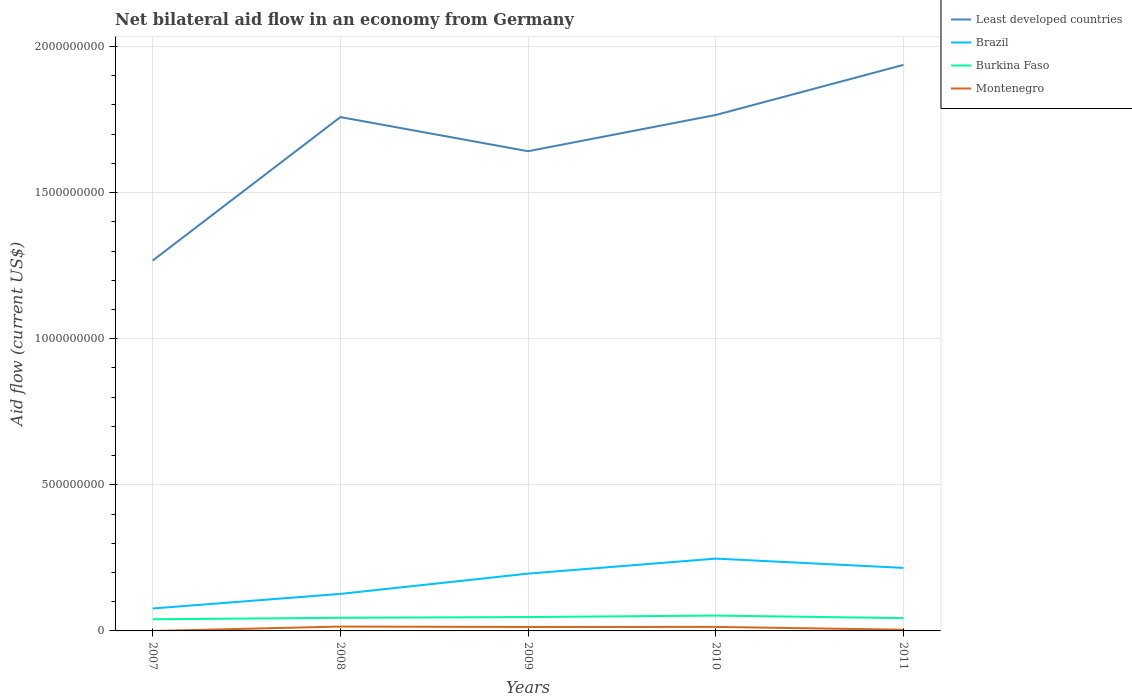How many different coloured lines are there?
Your answer should be compact. 4. Does the line corresponding to Brazil intersect with the line corresponding to Burkina Faso?
Your response must be concise. No. Across all years, what is the maximum net bilateral aid flow in Least developed countries?
Ensure brevity in your answer.  1.27e+09. What is the total net bilateral aid flow in Burkina Faso in the graph?
Offer a terse response. -3.88e+06. What is the difference between the highest and the second highest net bilateral aid flow in Least developed countries?
Offer a very short reply. 6.70e+08. Is the net bilateral aid flow in Least developed countries strictly greater than the net bilateral aid flow in Brazil over the years?
Provide a short and direct response. No. How many years are there in the graph?
Your answer should be compact. 5. What is the difference between two consecutive major ticks on the Y-axis?
Give a very brief answer. 5.00e+08. Are the values on the major ticks of Y-axis written in scientific E-notation?
Your answer should be very brief. No. Does the graph contain any zero values?
Your answer should be very brief. Yes. Does the graph contain grids?
Make the answer very short. Yes. Where does the legend appear in the graph?
Your answer should be compact. Top right. How are the legend labels stacked?
Offer a very short reply. Vertical. What is the title of the graph?
Your answer should be compact. Net bilateral aid flow in an economy from Germany. What is the label or title of the X-axis?
Make the answer very short. Years. What is the Aid flow (current US$) of Least developed countries in 2007?
Your response must be concise. 1.27e+09. What is the Aid flow (current US$) in Brazil in 2007?
Your response must be concise. 7.68e+07. What is the Aid flow (current US$) of Burkina Faso in 2007?
Provide a short and direct response. 3.99e+07. What is the Aid flow (current US$) of Least developed countries in 2008?
Provide a short and direct response. 1.76e+09. What is the Aid flow (current US$) of Brazil in 2008?
Provide a short and direct response. 1.27e+08. What is the Aid flow (current US$) of Burkina Faso in 2008?
Provide a short and direct response. 4.49e+07. What is the Aid flow (current US$) in Montenegro in 2008?
Provide a short and direct response. 1.49e+07. What is the Aid flow (current US$) in Least developed countries in 2009?
Provide a succinct answer. 1.64e+09. What is the Aid flow (current US$) in Brazil in 2009?
Provide a succinct answer. 1.96e+08. What is the Aid flow (current US$) in Burkina Faso in 2009?
Offer a very short reply. 4.75e+07. What is the Aid flow (current US$) in Montenegro in 2009?
Provide a short and direct response. 1.35e+07. What is the Aid flow (current US$) in Least developed countries in 2010?
Make the answer very short. 1.77e+09. What is the Aid flow (current US$) of Brazil in 2010?
Ensure brevity in your answer.  2.47e+08. What is the Aid flow (current US$) of Burkina Faso in 2010?
Offer a very short reply. 5.25e+07. What is the Aid flow (current US$) of Montenegro in 2010?
Make the answer very short. 1.38e+07. What is the Aid flow (current US$) in Least developed countries in 2011?
Your answer should be very brief. 1.94e+09. What is the Aid flow (current US$) of Brazil in 2011?
Offer a terse response. 2.16e+08. What is the Aid flow (current US$) in Burkina Faso in 2011?
Make the answer very short. 4.38e+07. What is the Aid flow (current US$) in Montenegro in 2011?
Make the answer very short. 4.08e+06. Across all years, what is the maximum Aid flow (current US$) of Least developed countries?
Your answer should be compact. 1.94e+09. Across all years, what is the maximum Aid flow (current US$) of Brazil?
Your answer should be compact. 2.47e+08. Across all years, what is the maximum Aid flow (current US$) of Burkina Faso?
Make the answer very short. 5.25e+07. Across all years, what is the maximum Aid flow (current US$) of Montenegro?
Your answer should be compact. 1.49e+07. Across all years, what is the minimum Aid flow (current US$) of Least developed countries?
Give a very brief answer. 1.27e+09. Across all years, what is the minimum Aid flow (current US$) in Brazil?
Offer a terse response. 7.68e+07. Across all years, what is the minimum Aid flow (current US$) in Burkina Faso?
Provide a succinct answer. 3.99e+07. Across all years, what is the minimum Aid flow (current US$) in Montenegro?
Keep it short and to the point. 0. What is the total Aid flow (current US$) of Least developed countries in the graph?
Ensure brevity in your answer.  8.37e+09. What is the total Aid flow (current US$) of Brazil in the graph?
Your response must be concise. 8.63e+08. What is the total Aid flow (current US$) of Burkina Faso in the graph?
Give a very brief answer. 2.29e+08. What is the total Aid flow (current US$) in Montenegro in the graph?
Ensure brevity in your answer.  4.62e+07. What is the difference between the Aid flow (current US$) in Least developed countries in 2007 and that in 2008?
Ensure brevity in your answer.  -4.91e+08. What is the difference between the Aid flow (current US$) of Brazil in 2007 and that in 2008?
Your answer should be compact. -4.98e+07. What is the difference between the Aid flow (current US$) of Burkina Faso in 2007 and that in 2008?
Your response must be concise. -5.02e+06. What is the difference between the Aid flow (current US$) in Least developed countries in 2007 and that in 2009?
Your answer should be very brief. -3.74e+08. What is the difference between the Aid flow (current US$) of Brazil in 2007 and that in 2009?
Offer a terse response. -1.19e+08. What is the difference between the Aid flow (current US$) in Burkina Faso in 2007 and that in 2009?
Offer a terse response. -7.60e+06. What is the difference between the Aid flow (current US$) of Least developed countries in 2007 and that in 2010?
Keep it short and to the point. -4.98e+08. What is the difference between the Aid flow (current US$) in Brazil in 2007 and that in 2010?
Your response must be concise. -1.71e+08. What is the difference between the Aid flow (current US$) of Burkina Faso in 2007 and that in 2010?
Keep it short and to the point. -1.26e+07. What is the difference between the Aid flow (current US$) of Least developed countries in 2007 and that in 2011?
Your answer should be compact. -6.70e+08. What is the difference between the Aid flow (current US$) in Brazil in 2007 and that in 2011?
Your answer should be compact. -1.39e+08. What is the difference between the Aid flow (current US$) of Burkina Faso in 2007 and that in 2011?
Your answer should be compact. -3.88e+06. What is the difference between the Aid flow (current US$) in Least developed countries in 2008 and that in 2009?
Ensure brevity in your answer.  1.17e+08. What is the difference between the Aid flow (current US$) of Brazil in 2008 and that in 2009?
Provide a short and direct response. -6.94e+07. What is the difference between the Aid flow (current US$) in Burkina Faso in 2008 and that in 2009?
Your response must be concise. -2.58e+06. What is the difference between the Aid flow (current US$) in Montenegro in 2008 and that in 2009?
Offer a very short reply. 1.44e+06. What is the difference between the Aid flow (current US$) of Least developed countries in 2008 and that in 2010?
Ensure brevity in your answer.  -7.21e+06. What is the difference between the Aid flow (current US$) of Brazil in 2008 and that in 2010?
Offer a very short reply. -1.21e+08. What is the difference between the Aid flow (current US$) in Burkina Faso in 2008 and that in 2010?
Offer a terse response. -7.59e+06. What is the difference between the Aid flow (current US$) of Montenegro in 2008 and that in 2010?
Provide a succinct answer. 1.17e+06. What is the difference between the Aid flow (current US$) of Least developed countries in 2008 and that in 2011?
Offer a terse response. -1.79e+08. What is the difference between the Aid flow (current US$) in Brazil in 2008 and that in 2011?
Ensure brevity in your answer.  -8.91e+07. What is the difference between the Aid flow (current US$) of Burkina Faso in 2008 and that in 2011?
Provide a short and direct response. 1.14e+06. What is the difference between the Aid flow (current US$) in Montenegro in 2008 and that in 2011?
Provide a short and direct response. 1.08e+07. What is the difference between the Aid flow (current US$) of Least developed countries in 2009 and that in 2010?
Your answer should be compact. -1.24e+08. What is the difference between the Aid flow (current US$) in Brazil in 2009 and that in 2010?
Offer a terse response. -5.14e+07. What is the difference between the Aid flow (current US$) in Burkina Faso in 2009 and that in 2010?
Provide a short and direct response. -5.01e+06. What is the difference between the Aid flow (current US$) of Montenegro in 2009 and that in 2010?
Provide a succinct answer. -2.70e+05. What is the difference between the Aid flow (current US$) of Least developed countries in 2009 and that in 2011?
Make the answer very short. -2.95e+08. What is the difference between the Aid flow (current US$) in Brazil in 2009 and that in 2011?
Offer a very short reply. -1.96e+07. What is the difference between the Aid flow (current US$) of Burkina Faso in 2009 and that in 2011?
Offer a very short reply. 3.72e+06. What is the difference between the Aid flow (current US$) in Montenegro in 2009 and that in 2011?
Provide a succinct answer. 9.40e+06. What is the difference between the Aid flow (current US$) in Least developed countries in 2010 and that in 2011?
Provide a short and direct response. -1.71e+08. What is the difference between the Aid flow (current US$) in Brazil in 2010 and that in 2011?
Your answer should be very brief. 3.17e+07. What is the difference between the Aid flow (current US$) in Burkina Faso in 2010 and that in 2011?
Ensure brevity in your answer.  8.73e+06. What is the difference between the Aid flow (current US$) in Montenegro in 2010 and that in 2011?
Your response must be concise. 9.67e+06. What is the difference between the Aid flow (current US$) in Least developed countries in 2007 and the Aid flow (current US$) in Brazil in 2008?
Provide a succinct answer. 1.14e+09. What is the difference between the Aid flow (current US$) of Least developed countries in 2007 and the Aid flow (current US$) of Burkina Faso in 2008?
Your answer should be very brief. 1.22e+09. What is the difference between the Aid flow (current US$) in Least developed countries in 2007 and the Aid flow (current US$) in Montenegro in 2008?
Your answer should be very brief. 1.25e+09. What is the difference between the Aid flow (current US$) of Brazil in 2007 and the Aid flow (current US$) of Burkina Faso in 2008?
Give a very brief answer. 3.19e+07. What is the difference between the Aid flow (current US$) of Brazil in 2007 and the Aid flow (current US$) of Montenegro in 2008?
Ensure brevity in your answer.  6.19e+07. What is the difference between the Aid flow (current US$) of Burkina Faso in 2007 and the Aid flow (current US$) of Montenegro in 2008?
Make the answer very short. 2.50e+07. What is the difference between the Aid flow (current US$) in Least developed countries in 2007 and the Aid flow (current US$) in Brazil in 2009?
Offer a terse response. 1.07e+09. What is the difference between the Aid flow (current US$) in Least developed countries in 2007 and the Aid flow (current US$) in Burkina Faso in 2009?
Your response must be concise. 1.22e+09. What is the difference between the Aid flow (current US$) of Least developed countries in 2007 and the Aid flow (current US$) of Montenegro in 2009?
Offer a very short reply. 1.25e+09. What is the difference between the Aid flow (current US$) in Brazil in 2007 and the Aid flow (current US$) in Burkina Faso in 2009?
Offer a very short reply. 2.93e+07. What is the difference between the Aid flow (current US$) in Brazil in 2007 and the Aid flow (current US$) in Montenegro in 2009?
Keep it short and to the point. 6.33e+07. What is the difference between the Aid flow (current US$) in Burkina Faso in 2007 and the Aid flow (current US$) in Montenegro in 2009?
Offer a terse response. 2.64e+07. What is the difference between the Aid flow (current US$) in Least developed countries in 2007 and the Aid flow (current US$) in Brazil in 2010?
Make the answer very short. 1.02e+09. What is the difference between the Aid flow (current US$) in Least developed countries in 2007 and the Aid flow (current US$) in Burkina Faso in 2010?
Offer a terse response. 1.21e+09. What is the difference between the Aid flow (current US$) of Least developed countries in 2007 and the Aid flow (current US$) of Montenegro in 2010?
Provide a succinct answer. 1.25e+09. What is the difference between the Aid flow (current US$) in Brazil in 2007 and the Aid flow (current US$) in Burkina Faso in 2010?
Offer a terse response. 2.43e+07. What is the difference between the Aid flow (current US$) of Brazil in 2007 and the Aid flow (current US$) of Montenegro in 2010?
Provide a short and direct response. 6.30e+07. What is the difference between the Aid flow (current US$) in Burkina Faso in 2007 and the Aid flow (current US$) in Montenegro in 2010?
Your response must be concise. 2.62e+07. What is the difference between the Aid flow (current US$) in Least developed countries in 2007 and the Aid flow (current US$) in Brazil in 2011?
Your answer should be compact. 1.05e+09. What is the difference between the Aid flow (current US$) of Least developed countries in 2007 and the Aid flow (current US$) of Burkina Faso in 2011?
Provide a succinct answer. 1.22e+09. What is the difference between the Aid flow (current US$) of Least developed countries in 2007 and the Aid flow (current US$) of Montenegro in 2011?
Provide a succinct answer. 1.26e+09. What is the difference between the Aid flow (current US$) of Brazil in 2007 and the Aid flow (current US$) of Burkina Faso in 2011?
Your answer should be very brief. 3.30e+07. What is the difference between the Aid flow (current US$) in Brazil in 2007 and the Aid flow (current US$) in Montenegro in 2011?
Make the answer very short. 7.27e+07. What is the difference between the Aid flow (current US$) in Burkina Faso in 2007 and the Aid flow (current US$) in Montenegro in 2011?
Make the answer very short. 3.58e+07. What is the difference between the Aid flow (current US$) of Least developed countries in 2008 and the Aid flow (current US$) of Brazil in 2009?
Your answer should be very brief. 1.56e+09. What is the difference between the Aid flow (current US$) of Least developed countries in 2008 and the Aid flow (current US$) of Burkina Faso in 2009?
Your answer should be compact. 1.71e+09. What is the difference between the Aid flow (current US$) in Least developed countries in 2008 and the Aid flow (current US$) in Montenegro in 2009?
Ensure brevity in your answer.  1.74e+09. What is the difference between the Aid flow (current US$) of Brazil in 2008 and the Aid flow (current US$) of Burkina Faso in 2009?
Ensure brevity in your answer.  7.92e+07. What is the difference between the Aid flow (current US$) of Brazil in 2008 and the Aid flow (current US$) of Montenegro in 2009?
Your answer should be compact. 1.13e+08. What is the difference between the Aid flow (current US$) of Burkina Faso in 2008 and the Aid flow (current US$) of Montenegro in 2009?
Offer a very short reply. 3.14e+07. What is the difference between the Aid flow (current US$) in Least developed countries in 2008 and the Aid flow (current US$) in Brazil in 2010?
Give a very brief answer. 1.51e+09. What is the difference between the Aid flow (current US$) in Least developed countries in 2008 and the Aid flow (current US$) in Burkina Faso in 2010?
Your answer should be compact. 1.71e+09. What is the difference between the Aid flow (current US$) in Least developed countries in 2008 and the Aid flow (current US$) in Montenegro in 2010?
Keep it short and to the point. 1.74e+09. What is the difference between the Aid flow (current US$) in Brazil in 2008 and the Aid flow (current US$) in Burkina Faso in 2010?
Make the answer very short. 7.41e+07. What is the difference between the Aid flow (current US$) in Brazil in 2008 and the Aid flow (current US$) in Montenegro in 2010?
Offer a very short reply. 1.13e+08. What is the difference between the Aid flow (current US$) of Burkina Faso in 2008 and the Aid flow (current US$) of Montenegro in 2010?
Make the answer very short. 3.12e+07. What is the difference between the Aid flow (current US$) in Least developed countries in 2008 and the Aid flow (current US$) in Brazil in 2011?
Ensure brevity in your answer.  1.54e+09. What is the difference between the Aid flow (current US$) of Least developed countries in 2008 and the Aid flow (current US$) of Burkina Faso in 2011?
Your answer should be compact. 1.71e+09. What is the difference between the Aid flow (current US$) in Least developed countries in 2008 and the Aid flow (current US$) in Montenegro in 2011?
Ensure brevity in your answer.  1.75e+09. What is the difference between the Aid flow (current US$) of Brazil in 2008 and the Aid flow (current US$) of Burkina Faso in 2011?
Your answer should be very brief. 8.29e+07. What is the difference between the Aid flow (current US$) in Brazil in 2008 and the Aid flow (current US$) in Montenegro in 2011?
Keep it short and to the point. 1.23e+08. What is the difference between the Aid flow (current US$) of Burkina Faso in 2008 and the Aid flow (current US$) of Montenegro in 2011?
Ensure brevity in your answer.  4.08e+07. What is the difference between the Aid flow (current US$) in Least developed countries in 2009 and the Aid flow (current US$) in Brazil in 2010?
Your response must be concise. 1.39e+09. What is the difference between the Aid flow (current US$) in Least developed countries in 2009 and the Aid flow (current US$) in Burkina Faso in 2010?
Ensure brevity in your answer.  1.59e+09. What is the difference between the Aid flow (current US$) in Least developed countries in 2009 and the Aid flow (current US$) in Montenegro in 2010?
Keep it short and to the point. 1.63e+09. What is the difference between the Aid flow (current US$) in Brazil in 2009 and the Aid flow (current US$) in Burkina Faso in 2010?
Offer a terse response. 1.44e+08. What is the difference between the Aid flow (current US$) of Brazil in 2009 and the Aid flow (current US$) of Montenegro in 2010?
Provide a succinct answer. 1.82e+08. What is the difference between the Aid flow (current US$) of Burkina Faso in 2009 and the Aid flow (current US$) of Montenegro in 2010?
Your answer should be very brief. 3.38e+07. What is the difference between the Aid flow (current US$) in Least developed countries in 2009 and the Aid flow (current US$) in Brazil in 2011?
Provide a short and direct response. 1.43e+09. What is the difference between the Aid flow (current US$) in Least developed countries in 2009 and the Aid flow (current US$) in Burkina Faso in 2011?
Your response must be concise. 1.60e+09. What is the difference between the Aid flow (current US$) of Least developed countries in 2009 and the Aid flow (current US$) of Montenegro in 2011?
Your answer should be very brief. 1.64e+09. What is the difference between the Aid flow (current US$) of Brazil in 2009 and the Aid flow (current US$) of Burkina Faso in 2011?
Ensure brevity in your answer.  1.52e+08. What is the difference between the Aid flow (current US$) in Brazil in 2009 and the Aid flow (current US$) in Montenegro in 2011?
Offer a very short reply. 1.92e+08. What is the difference between the Aid flow (current US$) in Burkina Faso in 2009 and the Aid flow (current US$) in Montenegro in 2011?
Offer a terse response. 4.34e+07. What is the difference between the Aid flow (current US$) of Least developed countries in 2010 and the Aid flow (current US$) of Brazil in 2011?
Your answer should be compact. 1.55e+09. What is the difference between the Aid flow (current US$) of Least developed countries in 2010 and the Aid flow (current US$) of Burkina Faso in 2011?
Make the answer very short. 1.72e+09. What is the difference between the Aid flow (current US$) of Least developed countries in 2010 and the Aid flow (current US$) of Montenegro in 2011?
Offer a terse response. 1.76e+09. What is the difference between the Aid flow (current US$) in Brazil in 2010 and the Aid flow (current US$) in Burkina Faso in 2011?
Your answer should be very brief. 2.04e+08. What is the difference between the Aid flow (current US$) of Brazil in 2010 and the Aid flow (current US$) of Montenegro in 2011?
Your response must be concise. 2.43e+08. What is the difference between the Aid flow (current US$) in Burkina Faso in 2010 and the Aid flow (current US$) in Montenegro in 2011?
Give a very brief answer. 4.84e+07. What is the average Aid flow (current US$) in Least developed countries per year?
Ensure brevity in your answer.  1.67e+09. What is the average Aid flow (current US$) in Brazil per year?
Provide a succinct answer. 1.73e+08. What is the average Aid flow (current US$) in Burkina Faso per year?
Provide a short and direct response. 4.57e+07. What is the average Aid flow (current US$) of Montenegro per year?
Offer a terse response. 9.25e+06. In the year 2007, what is the difference between the Aid flow (current US$) in Least developed countries and Aid flow (current US$) in Brazil?
Offer a very short reply. 1.19e+09. In the year 2007, what is the difference between the Aid flow (current US$) in Least developed countries and Aid flow (current US$) in Burkina Faso?
Make the answer very short. 1.23e+09. In the year 2007, what is the difference between the Aid flow (current US$) of Brazil and Aid flow (current US$) of Burkina Faso?
Your response must be concise. 3.69e+07. In the year 2008, what is the difference between the Aid flow (current US$) of Least developed countries and Aid flow (current US$) of Brazil?
Offer a very short reply. 1.63e+09. In the year 2008, what is the difference between the Aid flow (current US$) in Least developed countries and Aid flow (current US$) in Burkina Faso?
Offer a terse response. 1.71e+09. In the year 2008, what is the difference between the Aid flow (current US$) of Least developed countries and Aid flow (current US$) of Montenegro?
Ensure brevity in your answer.  1.74e+09. In the year 2008, what is the difference between the Aid flow (current US$) of Brazil and Aid flow (current US$) of Burkina Faso?
Provide a short and direct response. 8.17e+07. In the year 2008, what is the difference between the Aid flow (current US$) in Brazil and Aid flow (current US$) in Montenegro?
Give a very brief answer. 1.12e+08. In the year 2008, what is the difference between the Aid flow (current US$) of Burkina Faso and Aid flow (current US$) of Montenegro?
Ensure brevity in your answer.  3.00e+07. In the year 2009, what is the difference between the Aid flow (current US$) of Least developed countries and Aid flow (current US$) of Brazil?
Offer a terse response. 1.45e+09. In the year 2009, what is the difference between the Aid flow (current US$) of Least developed countries and Aid flow (current US$) of Burkina Faso?
Ensure brevity in your answer.  1.59e+09. In the year 2009, what is the difference between the Aid flow (current US$) in Least developed countries and Aid flow (current US$) in Montenegro?
Provide a short and direct response. 1.63e+09. In the year 2009, what is the difference between the Aid flow (current US$) of Brazil and Aid flow (current US$) of Burkina Faso?
Make the answer very short. 1.49e+08. In the year 2009, what is the difference between the Aid flow (current US$) of Brazil and Aid flow (current US$) of Montenegro?
Keep it short and to the point. 1.83e+08. In the year 2009, what is the difference between the Aid flow (current US$) in Burkina Faso and Aid flow (current US$) in Montenegro?
Ensure brevity in your answer.  3.40e+07. In the year 2010, what is the difference between the Aid flow (current US$) in Least developed countries and Aid flow (current US$) in Brazil?
Your answer should be compact. 1.52e+09. In the year 2010, what is the difference between the Aid flow (current US$) in Least developed countries and Aid flow (current US$) in Burkina Faso?
Your response must be concise. 1.71e+09. In the year 2010, what is the difference between the Aid flow (current US$) in Least developed countries and Aid flow (current US$) in Montenegro?
Your response must be concise. 1.75e+09. In the year 2010, what is the difference between the Aid flow (current US$) of Brazil and Aid flow (current US$) of Burkina Faso?
Your answer should be very brief. 1.95e+08. In the year 2010, what is the difference between the Aid flow (current US$) of Brazil and Aid flow (current US$) of Montenegro?
Your answer should be compact. 2.34e+08. In the year 2010, what is the difference between the Aid flow (current US$) in Burkina Faso and Aid flow (current US$) in Montenegro?
Give a very brief answer. 3.88e+07. In the year 2011, what is the difference between the Aid flow (current US$) of Least developed countries and Aid flow (current US$) of Brazil?
Your response must be concise. 1.72e+09. In the year 2011, what is the difference between the Aid flow (current US$) of Least developed countries and Aid flow (current US$) of Burkina Faso?
Offer a very short reply. 1.89e+09. In the year 2011, what is the difference between the Aid flow (current US$) in Least developed countries and Aid flow (current US$) in Montenegro?
Keep it short and to the point. 1.93e+09. In the year 2011, what is the difference between the Aid flow (current US$) of Brazil and Aid flow (current US$) of Burkina Faso?
Make the answer very short. 1.72e+08. In the year 2011, what is the difference between the Aid flow (current US$) of Brazil and Aid flow (current US$) of Montenegro?
Offer a very short reply. 2.12e+08. In the year 2011, what is the difference between the Aid flow (current US$) in Burkina Faso and Aid flow (current US$) in Montenegro?
Ensure brevity in your answer.  3.97e+07. What is the ratio of the Aid flow (current US$) in Least developed countries in 2007 to that in 2008?
Offer a terse response. 0.72. What is the ratio of the Aid flow (current US$) of Brazil in 2007 to that in 2008?
Ensure brevity in your answer.  0.61. What is the ratio of the Aid flow (current US$) in Burkina Faso in 2007 to that in 2008?
Your answer should be compact. 0.89. What is the ratio of the Aid flow (current US$) of Least developed countries in 2007 to that in 2009?
Offer a terse response. 0.77. What is the ratio of the Aid flow (current US$) of Brazil in 2007 to that in 2009?
Provide a short and direct response. 0.39. What is the ratio of the Aid flow (current US$) in Burkina Faso in 2007 to that in 2009?
Offer a very short reply. 0.84. What is the ratio of the Aid flow (current US$) of Least developed countries in 2007 to that in 2010?
Offer a very short reply. 0.72. What is the ratio of the Aid flow (current US$) in Brazil in 2007 to that in 2010?
Keep it short and to the point. 0.31. What is the ratio of the Aid flow (current US$) in Burkina Faso in 2007 to that in 2010?
Make the answer very short. 0.76. What is the ratio of the Aid flow (current US$) of Least developed countries in 2007 to that in 2011?
Offer a terse response. 0.65. What is the ratio of the Aid flow (current US$) of Brazil in 2007 to that in 2011?
Your answer should be very brief. 0.36. What is the ratio of the Aid flow (current US$) of Burkina Faso in 2007 to that in 2011?
Ensure brevity in your answer.  0.91. What is the ratio of the Aid flow (current US$) of Least developed countries in 2008 to that in 2009?
Your answer should be compact. 1.07. What is the ratio of the Aid flow (current US$) of Brazil in 2008 to that in 2009?
Your answer should be compact. 0.65. What is the ratio of the Aid flow (current US$) in Burkina Faso in 2008 to that in 2009?
Make the answer very short. 0.95. What is the ratio of the Aid flow (current US$) in Montenegro in 2008 to that in 2009?
Provide a short and direct response. 1.11. What is the ratio of the Aid flow (current US$) of Brazil in 2008 to that in 2010?
Keep it short and to the point. 0.51. What is the ratio of the Aid flow (current US$) in Burkina Faso in 2008 to that in 2010?
Your answer should be compact. 0.86. What is the ratio of the Aid flow (current US$) in Montenegro in 2008 to that in 2010?
Your answer should be very brief. 1.09. What is the ratio of the Aid flow (current US$) in Least developed countries in 2008 to that in 2011?
Ensure brevity in your answer.  0.91. What is the ratio of the Aid flow (current US$) of Brazil in 2008 to that in 2011?
Offer a terse response. 0.59. What is the ratio of the Aid flow (current US$) of Montenegro in 2008 to that in 2011?
Keep it short and to the point. 3.66. What is the ratio of the Aid flow (current US$) of Least developed countries in 2009 to that in 2010?
Keep it short and to the point. 0.93. What is the ratio of the Aid flow (current US$) of Brazil in 2009 to that in 2010?
Ensure brevity in your answer.  0.79. What is the ratio of the Aid flow (current US$) of Burkina Faso in 2009 to that in 2010?
Provide a succinct answer. 0.9. What is the ratio of the Aid flow (current US$) of Montenegro in 2009 to that in 2010?
Your answer should be compact. 0.98. What is the ratio of the Aid flow (current US$) of Least developed countries in 2009 to that in 2011?
Your response must be concise. 0.85. What is the ratio of the Aid flow (current US$) in Burkina Faso in 2009 to that in 2011?
Offer a terse response. 1.08. What is the ratio of the Aid flow (current US$) in Montenegro in 2009 to that in 2011?
Offer a terse response. 3.3. What is the ratio of the Aid flow (current US$) of Least developed countries in 2010 to that in 2011?
Provide a short and direct response. 0.91. What is the ratio of the Aid flow (current US$) of Brazil in 2010 to that in 2011?
Your response must be concise. 1.15. What is the ratio of the Aid flow (current US$) of Burkina Faso in 2010 to that in 2011?
Keep it short and to the point. 1.2. What is the ratio of the Aid flow (current US$) in Montenegro in 2010 to that in 2011?
Provide a short and direct response. 3.37. What is the difference between the highest and the second highest Aid flow (current US$) in Least developed countries?
Your answer should be very brief. 1.71e+08. What is the difference between the highest and the second highest Aid flow (current US$) in Brazil?
Offer a very short reply. 3.17e+07. What is the difference between the highest and the second highest Aid flow (current US$) of Burkina Faso?
Your response must be concise. 5.01e+06. What is the difference between the highest and the second highest Aid flow (current US$) of Montenegro?
Provide a succinct answer. 1.17e+06. What is the difference between the highest and the lowest Aid flow (current US$) in Least developed countries?
Your response must be concise. 6.70e+08. What is the difference between the highest and the lowest Aid flow (current US$) of Brazil?
Your answer should be compact. 1.71e+08. What is the difference between the highest and the lowest Aid flow (current US$) of Burkina Faso?
Your answer should be very brief. 1.26e+07. What is the difference between the highest and the lowest Aid flow (current US$) of Montenegro?
Your answer should be very brief. 1.49e+07. 